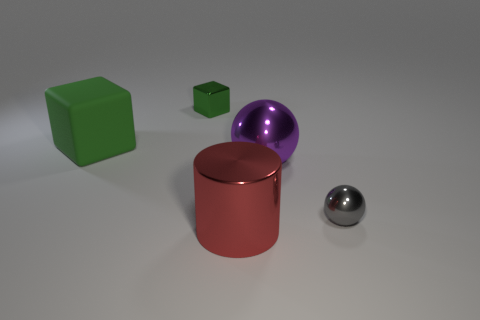What number of large objects are balls or blocks?
Offer a very short reply. 2. The large purple object that is made of the same material as the cylinder is what shape?
Offer a terse response. Sphere. Is the shape of the large purple metal thing the same as the green shiny object?
Provide a short and direct response. No. The metal cylinder is what color?
Offer a terse response. Red. What number of objects are small blue metal blocks or big green things?
Ensure brevity in your answer.  1. Is there anything else that is made of the same material as the large green block?
Your answer should be very brief. No. Are there fewer large red shiny objects in front of the gray shiny object than small objects?
Provide a short and direct response. Yes. Is the number of large matte blocks to the left of the tiny gray ball greater than the number of large red cylinders that are behind the rubber object?
Your response must be concise. Yes. Is there any other thing that is the same color as the large shiny cylinder?
Your answer should be compact. No. There is a large object behind the big purple shiny object; what is it made of?
Ensure brevity in your answer.  Rubber. 